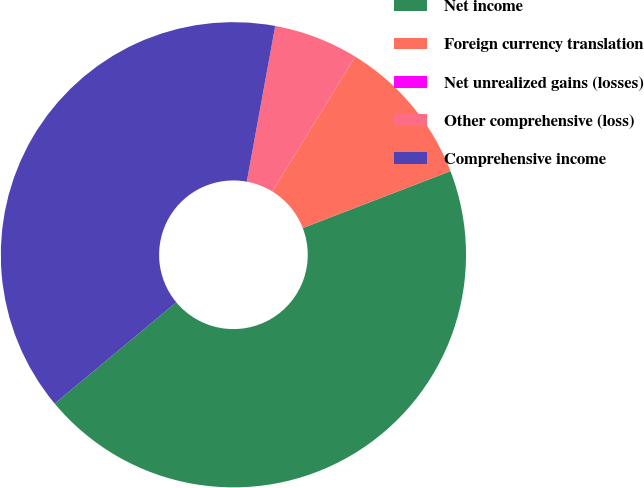Convert chart. <chart><loc_0><loc_0><loc_500><loc_500><pie_chart><fcel>Net income<fcel>Foreign currency translation<fcel>Net unrealized gains (losses)<fcel>Other comprehensive (loss)<fcel>Comprehensive income<nl><fcel>44.81%<fcel>10.37%<fcel>0.01%<fcel>5.89%<fcel>38.93%<nl></chart> 